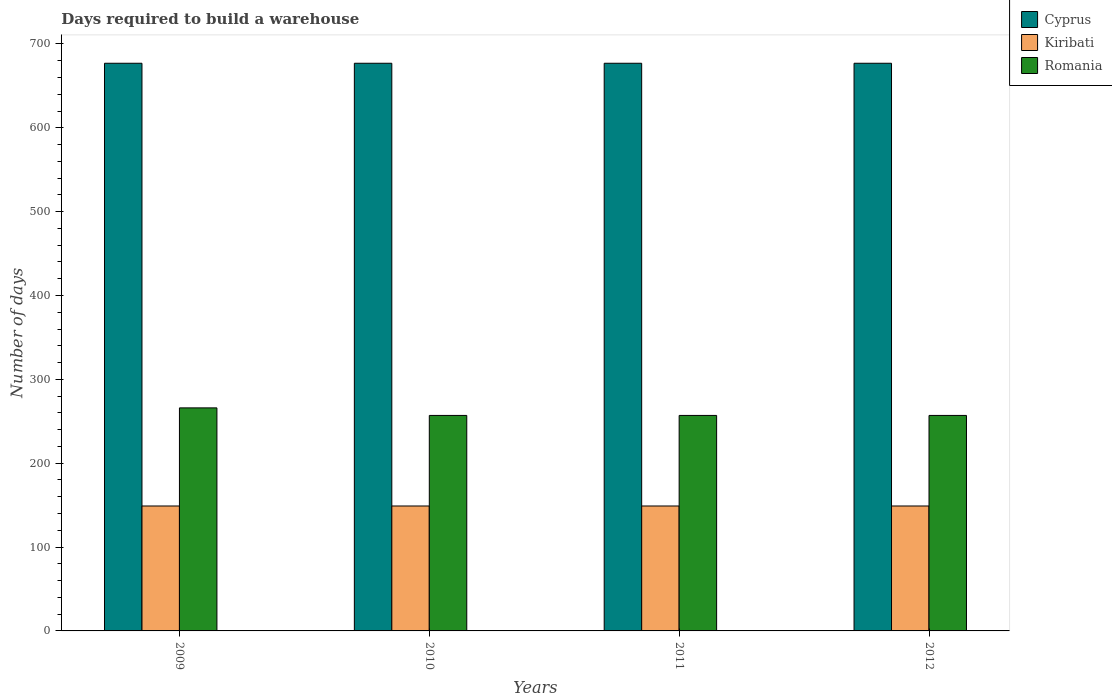How many bars are there on the 2nd tick from the left?
Provide a short and direct response. 3. In how many cases, is the number of bars for a given year not equal to the number of legend labels?
Your answer should be compact. 0. What is the days required to build a warehouse in in Romania in 2011?
Ensure brevity in your answer.  257. Across all years, what is the maximum days required to build a warehouse in in Romania?
Your answer should be very brief. 266. Across all years, what is the minimum days required to build a warehouse in in Kiribati?
Provide a succinct answer. 149. In which year was the days required to build a warehouse in in Kiribati minimum?
Ensure brevity in your answer.  2009. What is the total days required to build a warehouse in in Romania in the graph?
Keep it short and to the point. 1037. What is the difference between the days required to build a warehouse in in Cyprus in 2011 and the days required to build a warehouse in in Kiribati in 2010?
Ensure brevity in your answer.  528. What is the average days required to build a warehouse in in Kiribati per year?
Make the answer very short. 149. In the year 2011, what is the difference between the days required to build a warehouse in in Kiribati and days required to build a warehouse in in Cyprus?
Make the answer very short. -528. In how many years, is the days required to build a warehouse in in Cyprus greater than 540 days?
Offer a terse response. 4. Is the days required to build a warehouse in in Kiribati in 2011 less than that in 2012?
Provide a short and direct response. No. Is the difference between the days required to build a warehouse in in Kiribati in 2010 and 2012 greater than the difference between the days required to build a warehouse in in Cyprus in 2010 and 2012?
Your response must be concise. No. What is the difference between the highest and the lowest days required to build a warehouse in in Romania?
Ensure brevity in your answer.  9. In how many years, is the days required to build a warehouse in in Kiribati greater than the average days required to build a warehouse in in Kiribati taken over all years?
Make the answer very short. 0. Is the sum of the days required to build a warehouse in in Romania in 2009 and 2010 greater than the maximum days required to build a warehouse in in Cyprus across all years?
Your answer should be very brief. No. What does the 3rd bar from the left in 2009 represents?
Your answer should be very brief. Romania. What does the 2nd bar from the right in 2010 represents?
Ensure brevity in your answer.  Kiribati. How many bars are there?
Your answer should be very brief. 12. What is the difference between two consecutive major ticks on the Y-axis?
Give a very brief answer. 100. Does the graph contain any zero values?
Ensure brevity in your answer.  No. How are the legend labels stacked?
Your answer should be compact. Vertical. What is the title of the graph?
Ensure brevity in your answer.  Days required to build a warehouse. Does "Kosovo" appear as one of the legend labels in the graph?
Keep it short and to the point. No. What is the label or title of the Y-axis?
Provide a short and direct response. Number of days. What is the Number of days in Cyprus in 2009?
Offer a terse response. 677. What is the Number of days of Kiribati in 2009?
Provide a succinct answer. 149. What is the Number of days of Romania in 2009?
Provide a short and direct response. 266. What is the Number of days in Cyprus in 2010?
Provide a succinct answer. 677. What is the Number of days of Kiribati in 2010?
Make the answer very short. 149. What is the Number of days of Romania in 2010?
Offer a very short reply. 257. What is the Number of days in Cyprus in 2011?
Your response must be concise. 677. What is the Number of days of Kiribati in 2011?
Offer a very short reply. 149. What is the Number of days of Romania in 2011?
Your response must be concise. 257. What is the Number of days in Cyprus in 2012?
Your answer should be very brief. 677. What is the Number of days in Kiribati in 2012?
Your answer should be compact. 149. What is the Number of days of Romania in 2012?
Give a very brief answer. 257. Across all years, what is the maximum Number of days of Cyprus?
Offer a very short reply. 677. Across all years, what is the maximum Number of days in Kiribati?
Make the answer very short. 149. Across all years, what is the maximum Number of days in Romania?
Offer a very short reply. 266. Across all years, what is the minimum Number of days of Cyprus?
Ensure brevity in your answer.  677. Across all years, what is the minimum Number of days of Kiribati?
Offer a very short reply. 149. Across all years, what is the minimum Number of days in Romania?
Make the answer very short. 257. What is the total Number of days of Cyprus in the graph?
Provide a short and direct response. 2708. What is the total Number of days of Kiribati in the graph?
Offer a very short reply. 596. What is the total Number of days in Romania in the graph?
Offer a very short reply. 1037. What is the difference between the Number of days in Cyprus in 2009 and that in 2010?
Provide a succinct answer. 0. What is the difference between the Number of days in Romania in 2009 and that in 2010?
Provide a short and direct response. 9. What is the difference between the Number of days in Cyprus in 2009 and that in 2011?
Your response must be concise. 0. What is the difference between the Number of days in Romania in 2009 and that in 2011?
Offer a very short reply. 9. What is the difference between the Number of days of Romania in 2009 and that in 2012?
Give a very brief answer. 9. What is the difference between the Number of days of Kiribati in 2010 and that in 2011?
Make the answer very short. 0. What is the difference between the Number of days in Kiribati in 2010 and that in 2012?
Offer a terse response. 0. What is the difference between the Number of days in Cyprus in 2011 and that in 2012?
Provide a short and direct response. 0. What is the difference between the Number of days of Romania in 2011 and that in 2012?
Your answer should be very brief. 0. What is the difference between the Number of days of Cyprus in 2009 and the Number of days of Kiribati in 2010?
Provide a short and direct response. 528. What is the difference between the Number of days of Cyprus in 2009 and the Number of days of Romania in 2010?
Offer a very short reply. 420. What is the difference between the Number of days of Kiribati in 2009 and the Number of days of Romania in 2010?
Keep it short and to the point. -108. What is the difference between the Number of days in Cyprus in 2009 and the Number of days in Kiribati in 2011?
Give a very brief answer. 528. What is the difference between the Number of days of Cyprus in 2009 and the Number of days of Romania in 2011?
Ensure brevity in your answer.  420. What is the difference between the Number of days in Kiribati in 2009 and the Number of days in Romania in 2011?
Offer a terse response. -108. What is the difference between the Number of days of Cyprus in 2009 and the Number of days of Kiribati in 2012?
Your response must be concise. 528. What is the difference between the Number of days in Cyprus in 2009 and the Number of days in Romania in 2012?
Your response must be concise. 420. What is the difference between the Number of days of Kiribati in 2009 and the Number of days of Romania in 2012?
Provide a short and direct response. -108. What is the difference between the Number of days of Cyprus in 2010 and the Number of days of Kiribati in 2011?
Ensure brevity in your answer.  528. What is the difference between the Number of days of Cyprus in 2010 and the Number of days of Romania in 2011?
Your response must be concise. 420. What is the difference between the Number of days in Kiribati in 2010 and the Number of days in Romania in 2011?
Provide a succinct answer. -108. What is the difference between the Number of days of Cyprus in 2010 and the Number of days of Kiribati in 2012?
Keep it short and to the point. 528. What is the difference between the Number of days of Cyprus in 2010 and the Number of days of Romania in 2012?
Offer a very short reply. 420. What is the difference between the Number of days in Kiribati in 2010 and the Number of days in Romania in 2012?
Your response must be concise. -108. What is the difference between the Number of days of Cyprus in 2011 and the Number of days of Kiribati in 2012?
Your answer should be very brief. 528. What is the difference between the Number of days of Cyprus in 2011 and the Number of days of Romania in 2012?
Your answer should be very brief. 420. What is the difference between the Number of days in Kiribati in 2011 and the Number of days in Romania in 2012?
Provide a succinct answer. -108. What is the average Number of days in Cyprus per year?
Make the answer very short. 677. What is the average Number of days in Kiribati per year?
Ensure brevity in your answer.  149. What is the average Number of days in Romania per year?
Provide a short and direct response. 259.25. In the year 2009, what is the difference between the Number of days of Cyprus and Number of days of Kiribati?
Provide a short and direct response. 528. In the year 2009, what is the difference between the Number of days in Cyprus and Number of days in Romania?
Keep it short and to the point. 411. In the year 2009, what is the difference between the Number of days in Kiribati and Number of days in Romania?
Provide a succinct answer. -117. In the year 2010, what is the difference between the Number of days of Cyprus and Number of days of Kiribati?
Your response must be concise. 528. In the year 2010, what is the difference between the Number of days in Cyprus and Number of days in Romania?
Make the answer very short. 420. In the year 2010, what is the difference between the Number of days in Kiribati and Number of days in Romania?
Make the answer very short. -108. In the year 2011, what is the difference between the Number of days of Cyprus and Number of days of Kiribati?
Make the answer very short. 528. In the year 2011, what is the difference between the Number of days of Cyprus and Number of days of Romania?
Offer a very short reply. 420. In the year 2011, what is the difference between the Number of days in Kiribati and Number of days in Romania?
Your response must be concise. -108. In the year 2012, what is the difference between the Number of days in Cyprus and Number of days in Kiribati?
Your response must be concise. 528. In the year 2012, what is the difference between the Number of days in Cyprus and Number of days in Romania?
Make the answer very short. 420. In the year 2012, what is the difference between the Number of days in Kiribati and Number of days in Romania?
Provide a succinct answer. -108. What is the ratio of the Number of days in Cyprus in 2009 to that in 2010?
Give a very brief answer. 1. What is the ratio of the Number of days of Kiribati in 2009 to that in 2010?
Your answer should be very brief. 1. What is the ratio of the Number of days of Romania in 2009 to that in 2010?
Ensure brevity in your answer.  1.03. What is the ratio of the Number of days of Cyprus in 2009 to that in 2011?
Ensure brevity in your answer.  1. What is the ratio of the Number of days of Romania in 2009 to that in 2011?
Provide a short and direct response. 1.03. What is the ratio of the Number of days of Cyprus in 2009 to that in 2012?
Provide a succinct answer. 1. What is the ratio of the Number of days of Romania in 2009 to that in 2012?
Offer a very short reply. 1.03. What is the ratio of the Number of days of Kiribati in 2010 to that in 2011?
Provide a succinct answer. 1. What is the ratio of the Number of days in Kiribati in 2010 to that in 2012?
Make the answer very short. 1. What is the ratio of the Number of days in Romania in 2010 to that in 2012?
Make the answer very short. 1. What is the ratio of the Number of days in Kiribati in 2011 to that in 2012?
Provide a succinct answer. 1. What is the difference between the highest and the second highest Number of days of Cyprus?
Offer a very short reply. 0. What is the difference between the highest and the second highest Number of days in Kiribati?
Your response must be concise. 0. What is the difference between the highest and the second highest Number of days of Romania?
Give a very brief answer. 9. What is the difference between the highest and the lowest Number of days of Romania?
Give a very brief answer. 9. 